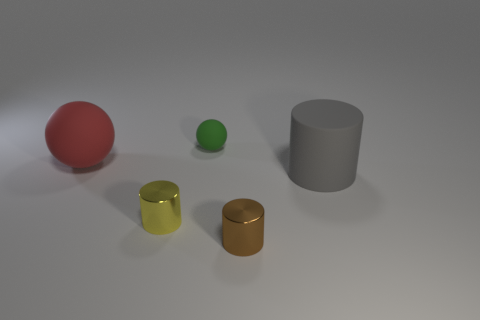Subtract 1 cylinders. How many cylinders are left? 2 Subtract all metal cylinders. How many cylinders are left? 1 Add 2 red shiny cylinders. How many objects exist? 7 Subtract all spheres. How many objects are left? 3 Subtract all big rubber cylinders. Subtract all brown cylinders. How many objects are left? 3 Add 4 small shiny cylinders. How many small shiny cylinders are left? 6 Add 1 green rubber balls. How many green rubber balls exist? 2 Subtract 0 brown blocks. How many objects are left? 5 